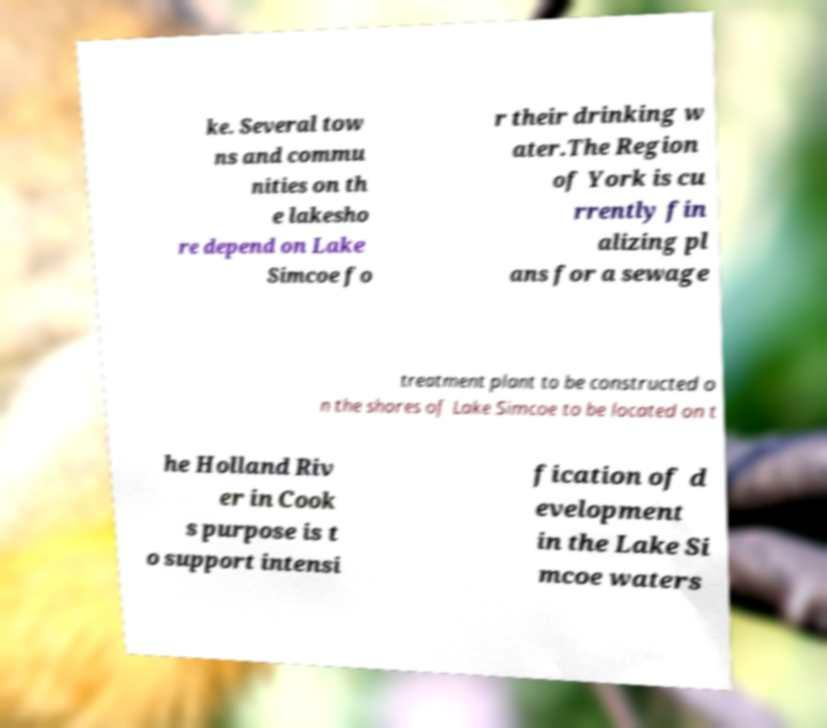Can you accurately transcribe the text from the provided image for me? ke. Several tow ns and commu nities on th e lakesho re depend on Lake Simcoe fo r their drinking w ater.The Region of York is cu rrently fin alizing pl ans for a sewage treatment plant to be constructed o n the shores of Lake Simcoe to be located on t he Holland Riv er in Cook s purpose is t o support intensi fication of d evelopment in the Lake Si mcoe waters 